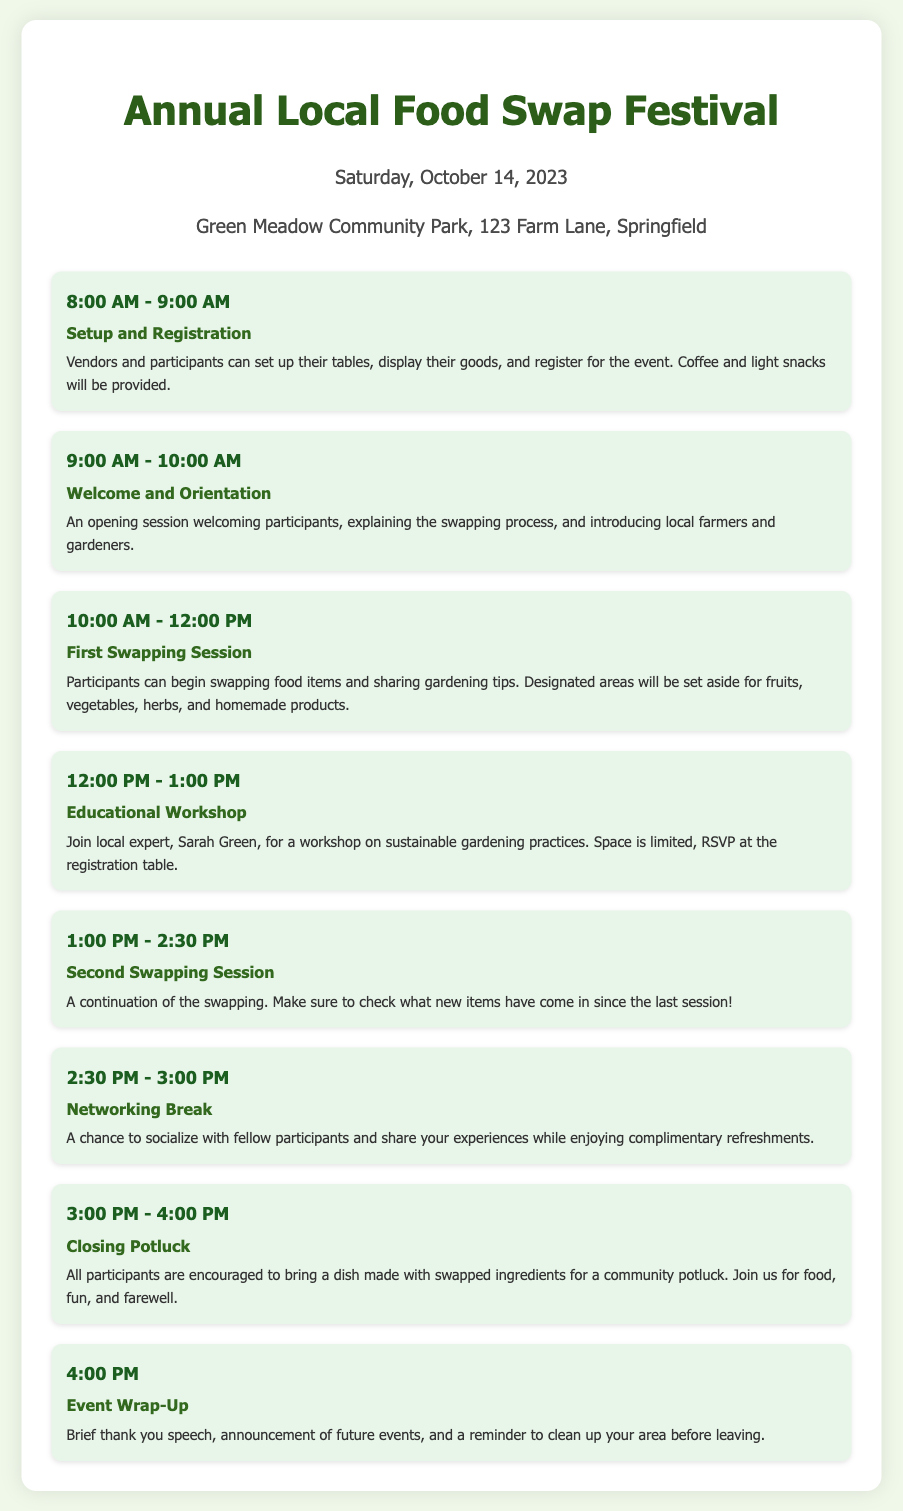What time does setup and registration start? The setup and registration time is explicitly mentioned in the document as starting at 8:00 AM.
Answer: 8:00 AM Who will conduct the educational workshop? The document states that the educational workshop will be conducted by local expert Sarah Green.
Answer: Sarah Green How long is the first swapping session? The duration of the first swapping session is provided in the schedule as 2 hours.
Answer: 2 hours What is encouraged to bring to the closing potluck? The document specifies that all participants are encouraged to bring a dish made with swapped ingredients.
Answer: A dish made with swapped ingredients At what time does the event wrap-up occur? The wrap-up of the event is scheduled to happen at 4:00 PM according to the agenda.
Answer: 4:00 PM What type of break is scheduled after the second swapping session? The document mentions that there is a Networking Break scheduled after the second swapping session.
Answer: Networking Break How many swapping sessions are there in total? By reviewing the schedule, it's clear that there are two swapping sessions included in the agenda.
Answer: Two What will be provided during setup and registration? The agenda notes that coffee and light snacks will be provided during the setup and registration time.
Answer: Coffee and light snacks 